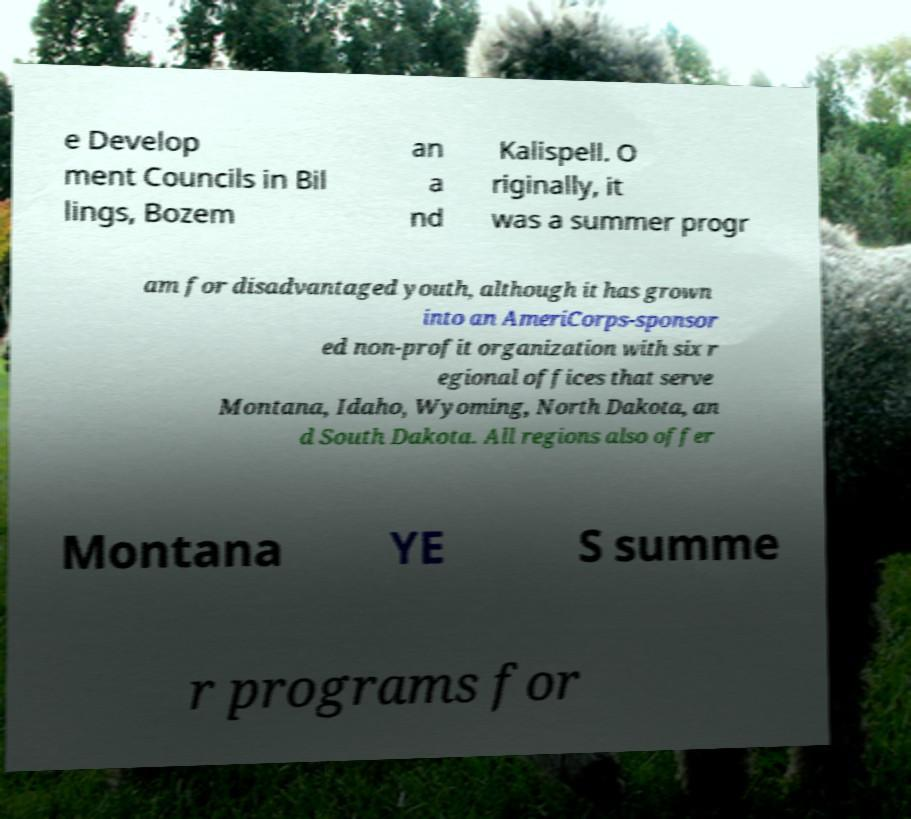Could you assist in decoding the text presented in this image and type it out clearly? e Develop ment Councils in Bil lings, Bozem an a nd Kalispell. O riginally, it was a summer progr am for disadvantaged youth, although it has grown into an AmeriCorps-sponsor ed non-profit organization with six r egional offices that serve Montana, Idaho, Wyoming, North Dakota, an d South Dakota. All regions also offer Montana YE S summe r programs for 